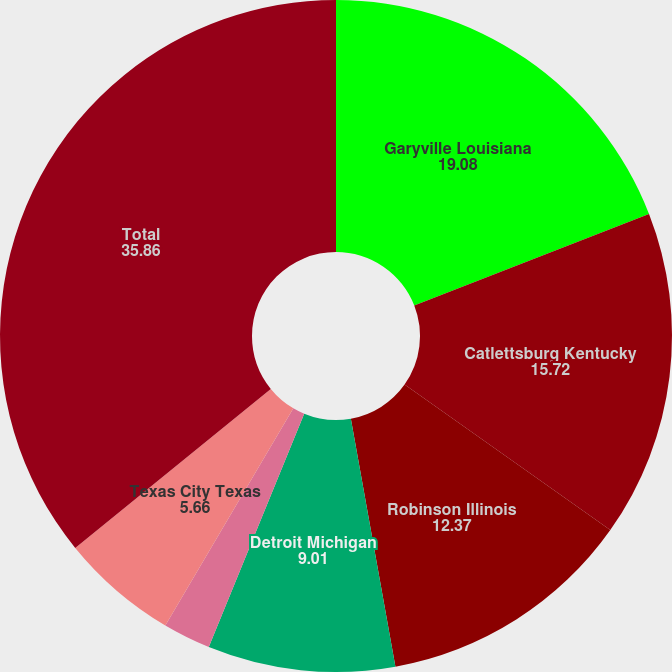<chart> <loc_0><loc_0><loc_500><loc_500><pie_chart><fcel>Garyville Louisiana<fcel>Catlettsburg Kentucky<fcel>Robinson Illinois<fcel>Detroit Michigan<fcel>Canton Ohio<fcel>Texas City Texas<fcel>Total<nl><fcel>19.08%<fcel>15.72%<fcel>12.37%<fcel>9.01%<fcel>2.3%<fcel>5.66%<fcel>35.86%<nl></chart> 